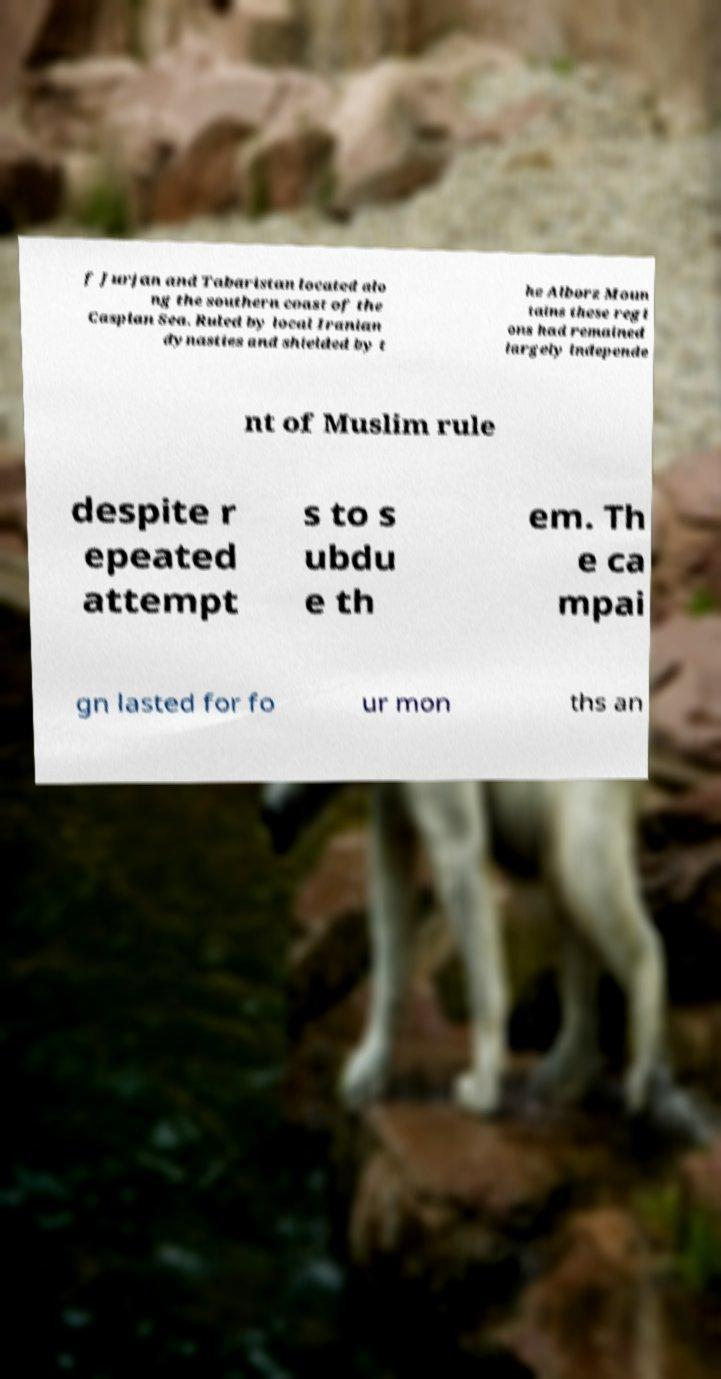What messages or text are displayed in this image? I need them in a readable, typed format. f Jurjan and Tabaristan located alo ng the southern coast of the Caspian Sea. Ruled by local Iranian dynasties and shielded by t he Alborz Moun tains these regi ons had remained largely independe nt of Muslim rule despite r epeated attempt s to s ubdu e th em. Th e ca mpai gn lasted for fo ur mon ths an 